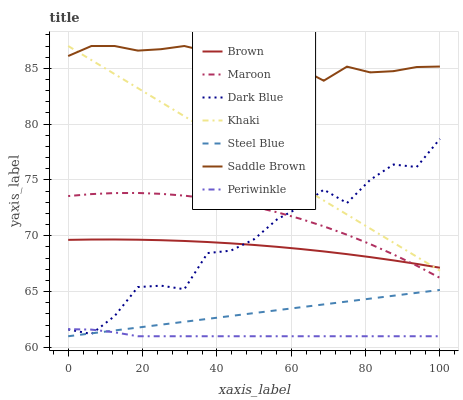Does Periwinkle have the minimum area under the curve?
Answer yes or no. Yes. Does Saddle Brown have the maximum area under the curve?
Answer yes or no. Yes. Does Khaki have the minimum area under the curve?
Answer yes or no. No. Does Khaki have the maximum area under the curve?
Answer yes or no. No. Is Steel Blue the smoothest?
Answer yes or no. Yes. Is Dark Blue the roughest?
Answer yes or no. Yes. Is Khaki the smoothest?
Answer yes or no. No. Is Khaki the roughest?
Answer yes or no. No. Does Steel Blue have the lowest value?
Answer yes or no. Yes. Does Khaki have the lowest value?
Answer yes or no. No. Does Saddle Brown have the highest value?
Answer yes or no. Yes. Does Steel Blue have the highest value?
Answer yes or no. No. Is Dark Blue less than Saddle Brown?
Answer yes or no. Yes. Is Brown greater than Periwinkle?
Answer yes or no. Yes. Does Saddle Brown intersect Khaki?
Answer yes or no. Yes. Is Saddle Brown less than Khaki?
Answer yes or no. No. Is Saddle Brown greater than Khaki?
Answer yes or no. No. Does Dark Blue intersect Saddle Brown?
Answer yes or no. No. 